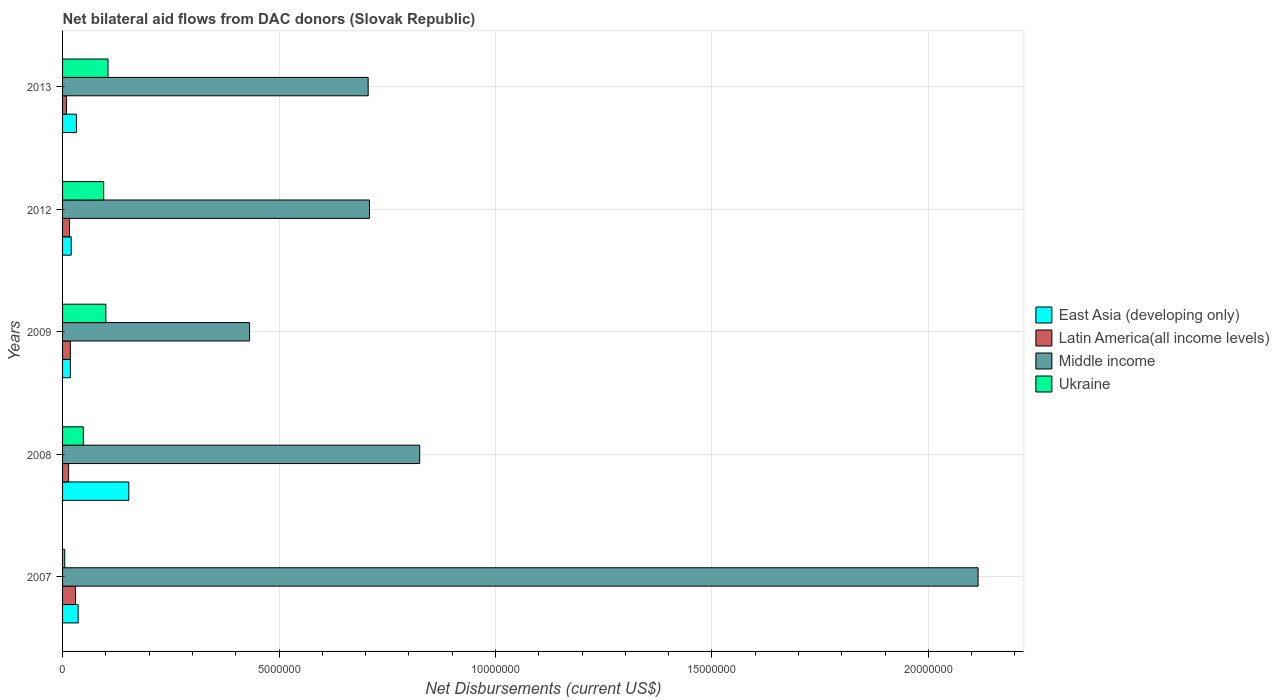How many groups of bars are there?
Your response must be concise. 5. Are the number of bars per tick equal to the number of legend labels?
Your response must be concise. Yes. Are the number of bars on each tick of the Y-axis equal?
Offer a terse response. Yes. How many bars are there on the 1st tick from the top?
Offer a very short reply. 4. What is the label of the 1st group of bars from the top?
Provide a succinct answer. 2013. What is the net bilateral aid flows in Middle income in 2012?
Provide a succinct answer. 7.09e+06. Across all years, what is the maximum net bilateral aid flows in Latin America(all income levels)?
Provide a short and direct response. 3.00e+05. What is the total net bilateral aid flows in Latin America(all income levels) in the graph?
Your response must be concise. 8.70e+05. What is the difference between the net bilateral aid flows in Middle income in 2008 and that in 2012?
Offer a very short reply. 1.16e+06. What is the difference between the net bilateral aid flows in Ukraine in 2009 and the net bilateral aid flows in Middle income in 2008?
Ensure brevity in your answer.  -7.25e+06. What is the average net bilateral aid flows in East Asia (developing only) per year?
Provide a short and direct response. 5.18e+05. In the year 2009, what is the difference between the net bilateral aid flows in East Asia (developing only) and net bilateral aid flows in Latin America(all income levels)?
Ensure brevity in your answer.  0. In how many years, is the net bilateral aid flows in Middle income greater than 2000000 US$?
Keep it short and to the point. 5. What is the ratio of the net bilateral aid flows in Middle income in 2008 to that in 2012?
Your answer should be compact. 1.16. Is the net bilateral aid flows in East Asia (developing only) in 2009 less than that in 2013?
Provide a short and direct response. Yes. Is the difference between the net bilateral aid flows in East Asia (developing only) in 2012 and 2013 greater than the difference between the net bilateral aid flows in Latin America(all income levels) in 2012 and 2013?
Your answer should be compact. No. What is the difference between the highest and the lowest net bilateral aid flows in Middle income?
Ensure brevity in your answer.  1.68e+07. In how many years, is the net bilateral aid flows in Ukraine greater than the average net bilateral aid flows in Ukraine taken over all years?
Offer a terse response. 3. Is the sum of the net bilateral aid flows in Middle income in 2007 and 2012 greater than the maximum net bilateral aid flows in Latin America(all income levels) across all years?
Provide a succinct answer. Yes. Is it the case that in every year, the sum of the net bilateral aid flows in Latin America(all income levels) and net bilateral aid flows in East Asia (developing only) is greater than the sum of net bilateral aid flows in Middle income and net bilateral aid flows in Ukraine?
Offer a terse response. Yes. What does the 1st bar from the top in 2007 represents?
Offer a terse response. Ukraine. What does the 1st bar from the bottom in 2008 represents?
Your response must be concise. East Asia (developing only). Is it the case that in every year, the sum of the net bilateral aid flows in Latin America(all income levels) and net bilateral aid flows in Ukraine is greater than the net bilateral aid flows in East Asia (developing only)?
Make the answer very short. No. Are all the bars in the graph horizontal?
Offer a terse response. Yes. How many years are there in the graph?
Offer a terse response. 5. What is the difference between two consecutive major ticks on the X-axis?
Your answer should be very brief. 5.00e+06. Are the values on the major ticks of X-axis written in scientific E-notation?
Offer a terse response. No. Does the graph contain grids?
Your answer should be compact. Yes. What is the title of the graph?
Your answer should be compact. Net bilateral aid flows from DAC donors (Slovak Republic). Does "Qatar" appear as one of the legend labels in the graph?
Give a very brief answer. No. What is the label or title of the X-axis?
Keep it short and to the point. Net Disbursements (current US$). What is the label or title of the Y-axis?
Give a very brief answer. Years. What is the Net Disbursements (current US$) in East Asia (developing only) in 2007?
Keep it short and to the point. 3.60e+05. What is the Net Disbursements (current US$) of Latin America(all income levels) in 2007?
Make the answer very short. 3.00e+05. What is the Net Disbursements (current US$) of Middle income in 2007?
Make the answer very short. 2.12e+07. What is the Net Disbursements (current US$) in Ukraine in 2007?
Your response must be concise. 5.00e+04. What is the Net Disbursements (current US$) of East Asia (developing only) in 2008?
Offer a very short reply. 1.53e+06. What is the Net Disbursements (current US$) in Middle income in 2008?
Your answer should be compact. 8.25e+06. What is the Net Disbursements (current US$) of Ukraine in 2008?
Provide a short and direct response. 4.80e+05. What is the Net Disbursements (current US$) of Middle income in 2009?
Provide a succinct answer. 4.32e+06. What is the Net Disbursements (current US$) of Latin America(all income levels) in 2012?
Offer a very short reply. 1.60e+05. What is the Net Disbursements (current US$) in Middle income in 2012?
Ensure brevity in your answer.  7.09e+06. What is the Net Disbursements (current US$) in Ukraine in 2012?
Provide a succinct answer. 9.50e+05. What is the Net Disbursements (current US$) of Latin America(all income levels) in 2013?
Ensure brevity in your answer.  9.00e+04. What is the Net Disbursements (current US$) in Middle income in 2013?
Your answer should be very brief. 7.06e+06. What is the Net Disbursements (current US$) in Ukraine in 2013?
Make the answer very short. 1.05e+06. Across all years, what is the maximum Net Disbursements (current US$) of East Asia (developing only)?
Your answer should be compact. 1.53e+06. Across all years, what is the maximum Net Disbursements (current US$) of Middle income?
Keep it short and to the point. 2.12e+07. Across all years, what is the maximum Net Disbursements (current US$) of Ukraine?
Your answer should be compact. 1.05e+06. Across all years, what is the minimum Net Disbursements (current US$) of East Asia (developing only)?
Provide a short and direct response. 1.80e+05. Across all years, what is the minimum Net Disbursements (current US$) of Middle income?
Make the answer very short. 4.32e+06. What is the total Net Disbursements (current US$) of East Asia (developing only) in the graph?
Keep it short and to the point. 2.59e+06. What is the total Net Disbursements (current US$) in Latin America(all income levels) in the graph?
Your answer should be compact. 8.70e+05. What is the total Net Disbursements (current US$) in Middle income in the graph?
Offer a terse response. 4.79e+07. What is the total Net Disbursements (current US$) in Ukraine in the graph?
Offer a terse response. 3.53e+06. What is the difference between the Net Disbursements (current US$) of East Asia (developing only) in 2007 and that in 2008?
Give a very brief answer. -1.17e+06. What is the difference between the Net Disbursements (current US$) of Latin America(all income levels) in 2007 and that in 2008?
Make the answer very short. 1.60e+05. What is the difference between the Net Disbursements (current US$) in Middle income in 2007 and that in 2008?
Your response must be concise. 1.29e+07. What is the difference between the Net Disbursements (current US$) in Ukraine in 2007 and that in 2008?
Provide a short and direct response. -4.30e+05. What is the difference between the Net Disbursements (current US$) of East Asia (developing only) in 2007 and that in 2009?
Your response must be concise. 1.80e+05. What is the difference between the Net Disbursements (current US$) of Middle income in 2007 and that in 2009?
Offer a very short reply. 1.68e+07. What is the difference between the Net Disbursements (current US$) of Ukraine in 2007 and that in 2009?
Offer a terse response. -9.50e+05. What is the difference between the Net Disbursements (current US$) of Middle income in 2007 and that in 2012?
Provide a succinct answer. 1.41e+07. What is the difference between the Net Disbursements (current US$) in Ukraine in 2007 and that in 2012?
Offer a very short reply. -9.00e+05. What is the difference between the Net Disbursements (current US$) of Middle income in 2007 and that in 2013?
Give a very brief answer. 1.41e+07. What is the difference between the Net Disbursements (current US$) in East Asia (developing only) in 2008 and that in 2009?
Provide a succinct answer. 1.35e+06. What is the difference between the Net Disbursements (current US$) of Latin America(all income levels) in 2008 and that in 2009?
Make the answer very short. -4.00e+04. What is the difference between the Net Disbursements (current US$) in Middle income in 2008 and that in 2009?
Provide a succinct answer. 3.93e+06. What is the difference between the Net Disbursements (current US$) in Ukraine in 2008 and that in 2009?
Offer a terse response. -5.20e+05. What is the difference between the Net Disbursements (current US$) in East Asia (developing only) in 2008 and that in 2012?
Ensure brevity in your answer.  1.33e+06. What is the difference between the Net Disbursements (current US$) in Latin America(all income levels) in 2008 and that in 2012?
Give a very brief answer. -2.00e+04. What is the difference between the Net Disbursements (current US$) in Middle income in 2008 and that in 2012?
Provide a succinct answer. 1.16e+06. What is the difference between the Net Disbursements (current US$) of Ukraine in 2008 and that in 2012?
Your response must be concise. -4.70e+05. What is the difference between the Net Disbursements (current US$) of East Asia (developing only) in 2008 and that in 2013?
Make the answer very short. 1.21e+06. What is the difference between the Net Disbursements (current US$) of Middle income in 2008 and that in 2013?
Make the answer very short. 1.19e+06. What is the difference between the Net Disbursements (current US$) of Ukraine in 2008 and that in 2013?
Give a very brief answer. -5.70e+05. What is the difference between the Net Disbursements (current US$) of East Asia (developing only) in 2009 and that in 2012?
Offer a very short reply. -2.00e+04. What is the difference between the Net Disbursements (current US$) of Latin America(all income levels) in 2009 and that in 2012?
Keep it short and to the point. 2.00e+04. What is the difference between the Net Disbursements (current US$) of Middle income in 2009 and that in 2012?
Keep it short and to the point. -2.77e+06. What is the difference between the Net Disbursements (current US$) of Ukraine in 2009 and that in 2012?
Your answer should be very brief. 5.00e+04. What is the difference between the Net Disbursements (current US$) of East Asia (developing only) in 2009 and that in 2013?
Provide a succinct answer. -1.40e+05. What is the difference between the Net Disbursements (current US$) of Latin America(all income levels) in 2009 and that in 2013?
Offer a very short reply. 9.00e+04. What is the difference between the Net Disbursements (current US$) in Middle income in 2009 and that in 2013?
Your response must be concise. -2.74e+06. What is the difference between the Net Disbursements (current US$) in East Asia (developing only) in 2012 and that in 2013?
Your response must be concise. -1.20e+05. What is the difference between the Net Disbursements (current US$) in Middle income in 2012 and that in 2013?
Provide a short and direct response. 3.00e+04. What is the difference between the Net Disbursements (current US$) in East Asia (developing only) in 2007 and the Net Disbursements (current US$) in Latin America(all income levels) in 2008?
Your answer should be compact. 2.20e+05. What is the difference between the Net Disbursements (current US$) in East Asia (developing only) in 2007 and the Net Disbursements (current US$) in Middle income in 2008?
Give a very brief answer. -7.89e+06. What is the difference between the Net Disbursements (current US$) of East Asia (developing only) in 2007 and the Net Disbursements (current US$) of Ukraine in 2008?
Keep it short and to the point. -1.20e+05. What is the difference between the Net Disbursements (current US$) of Latin America(all income levels) in 2007 and the Net Disbursements (current US$) of Middle income in 2008?
Your response must be concise. -7.95e+06. What is the difference between the Net Disbursements (current US$) of Middle income in 2007 and the Net Disbursements (current US$) of Ukraine in 2008?
Offer a terse response. 2.07e+07. What is the difference between the Net Disbursements (current US$) in East Asia (developing only) in 2007 and the Net Disbursements (current US$) in Middle income in 2009?
Offer a very short reply. -3.96e+06. What is the difference between the Net Disbursements (current US$) of East Asia (developing only) in 2007 and the Net Disbursements (current US$) of Ukraine in 2009?
Give a very brief answer. -6.40e+05. What is the difference between the Net Disbursements (current US$) of Latin America(all income levels) in 2007 and the Net Disbursements (current US$) of Middle income in 2009?
Keep it short and to the point. -4.02e+06. What is the difference between the Net Disbursements (current US$) in Latin America(all income levels) in 2007 and the Net Disbursements (current US$) in Ukraine in 2009?
Provide a succinct answer. -7.00e+05. What is the difference between the Net Disbursements (current US$) in Middle income in 2007 and the Net Disbursements (current US$) in Ukraine in 2009?
Your response must be concise. 2.02e+07. What is the difference between the Net Disbursements (current US$) in East Asia (developing only) in 2007 and the Net Disbursements (current US$) in Middle income in 2012?
Ensure brevity in your answer.  -6.73e+06. What is the difference between the Net Disbursements (current US$) in East Asia (developing only) in 2007 and the Net Disbursements (current US$) in Ukraine in 2012?
Your response must be concise. -5.90e+05. What is the difference between the Net Disbursements (current US$) of Latin America(all income levels) in 2007 and the Net Disbursements (current US$) of Middle income in 2012?
Keep it short and to the point. -6.79e+06. What is the difference between the Net Disbursements (current US$) in Latin America(all income levels) in 2007 and the Net Disbursements (current US$) in Ukraine in 2012?
Provide a succinct answer. -6.50e+05. What is the difference between the Net Disbursements (current US$) in Middle income in 2007 and the Net Disbursements (current US$) in Ukraine in 2012?
Make the answer very short. 2.02e+07. What is the difference between the Net Disbursements (current US$) in East Asia (developing only) in 2007 and the Net Disbursements (current US$) in Middle income in 2013?
Your response must be concise. -6.70e+06. What is the difference between the Net Disbursements (current US$) of East Asia (developing only) in 2007 and the Net Disbursements (current US$) of Ukraine in 2013?
Provide a short and direct response. -6.90e+05. What is the difference between the Net Disbursements (current US$) of Latin America(all income levels) in 2007 and the Net Disbursements (current US$) of Middle income in 2013?
Ensure brevity in your answer.  -6.76e+06. What is the difference between the Net Disbursements (current US$) in Latin America(all income levels) in 2007 and the Net Disbursements (current US$) in Ukraine in 2013?
Make the answer very short. -7.50e+05. What is the difference between the Net Disbursements (current US$) of Middle income in 2007 and the Net Disbursements (current US$) of Ukraine in 2013?
Your answer should be compact. 2.01e+07. What is the difference between the Net Disbursements (current US$) in East Asia (developing only) in 2008 and the Net Disbursements (current US$) in Latin America(all income levels) in 2009?
Your answer should be compact. 1.35e+06. What is the difference between the Net Disbursements (current US$) of East Asia (developing only) in 2008 and the Net Disbursements (current US$) of Middle income in 2009?
Your response must be concise. -2.79e+06. What is the difference between the Net Disbursements (current US$) in East Asia (developing only) in 2008 and the Net Disbursements (current US$) in Ukraine in 2009?
Offer a terse response. 5.30e+05. What is the difference between the Net Disbursements (current US$) in Latin America(all income levels) in 2008 and the Net Disbursements (current US$) in Middle income in 2009?
Your response must be concise. -4.18e+06. What is the difference between the Net Disbursements (current US$) of Latin America(all income levels) in 2008 and the Net Disbursements (current US$) of Ukraine in 2009?
Your answer should be compact. -8.60e+05. What is the difference between the Net Disbursements (current US$) in Middle income in 2008 and the Net Disbursements (current US$) in Ukraine in 2009?
Ensure brevity in your answer.  7.25e+06. What is the difference between the Net Disbursements (current US$) of East Asia (developing only) in 2008 and the Net Disbursements (current US$) of Latin America(all income levels) in 2012?
Your response must be concise. 1.37e+06. What is the difference between the Net Disbursements (current US$) in East Asia (developing only) in 2008 and the Net Disbursements (current US$) in Middle income in 2012?
Your response must be concise. -5.56e+06. What is the difference between the Net Disbursements (current US$) of East Asia (developing only) in 2008 and the Net Disbursements (current US$) of Ukraine in 2012?
Keep it short and to the point. 5.80e+05. What is the difference between the Net Disbursements (current US$) of Latin America(all income levels) in 2008 and the Net Disbursements (current US$) of Middle income in 2012?
Ensure brevity in your answer.  -6.95e+06. What is the difference between the Net Disbursements (current US$) in Latin America(all income levels) in 2008 and the Net Disbursements (current US$) in Ukraine in 2012?
Your answer should be very brief. -8.10e+05. What is the difference between the Net Disbursements (current US$) in Middle income in 2008 and the Net Disbursements (current US$) in Ukraine in 2012?
Offer a terse response. 7.30e+06. What is the difference between the Net Disbursements (current US$) in East Asia (developing only) in 2008 and the Net Disbursements (current US$) in Latin America(all income levels) in 2013?
Keep it short and to the point. 1.44e+06. What is the difference between the Net Disbursements (current US$) of East Asia (developing only) in 2008 and the Net Disbursements (current US$) of Middle income in 2013?
Offer a terse response. -5.53e+06. What is the difference between the Net Disbursements (current US$) of East Asia (developing only) in 2008 and the Net Disbursements (current US$) of Ukraine in 2013?
Give a very brief answer. 4.80e+05. What is the difference between the Net Disbursements (current US$) in Latin America(all income levels) in 2008 and the Net Disbursements (current US$) in Middle income in 2013?
Offer a terse response. -6.92e+06. What is the difference between the Net Disbursements (current US$) in Latin America(all income levels) in 2008 and the Net Disbursements (current US$) in Ukraine in 2013?
Your response must be concise. -9.10e+05. What is the difference between the Net Disbursements (current US$) of Middle income in 2008 and the Net Disbursements (current US$) of Ukraine in 2013?
Ensure brevity in your answer.  7.20e+06. What is the difference between the Net Disbursements (current US$) of East Asia (developing only) in 2009 and the Net Disbursements (current US$) of Middle income in 2012?
Offer a terse response. -6.91e+06. What is the difference between the Net Disbursements (current US$) of East Asia (developing only) in 2009 and the Net Disbursements (current US$) of Ukraine in 2012?
Keep it short and to the point. -7.70e+05. What is the difference between the Net Disbursements (current US$) of Latin America(all income levels) in 2009 and the Net Disbursements (current US$) of Middle income in 2012?
Provide a short and direct response. -6.91e+06. What is the difference between the Net Disbursements (current US$) of Latin America(all income levels) in 2009 and the Net Disbursements (current US$) of Ukraine in 2012?
Give a very brief answer. -7.70e+05. What is the difference between the Net Disbursements (current US$) of Middle income in 2009 and the Net Disbursements (current US$) of Ukraine in 2012?
Keep it short and to the point. 3.37e+06. What is the difference between the Net Disbursements (current US$) in East Asia (developing only) in 2009 and the Net Disbursements (current US$) in Middle income in 2013?
Keep it short and to the point. -6.88e+06. What is the difference between the Net Disbursements (current US$) in East Asia (developing only) in 2009 and the Net Disbursements (current US$) in Ukraine in 2013?
Keep it short and to the point. -8.70e+05. What is the difference between the Net Disbursements (current US$) in Latin America(all income levels) in 2009 and the Net Disbursements (current US$) in Middle income in 2013?
Provide a short and direct response. -6.88e+06. What is the difference between the Net Disbursements (current US$) in Latin America(all income levels) in 2009 and the Net Disbursements (current US$) in Ukraine in 2013?
Provide a short and direct response. -8.70e+05. What is the difference between the Net Disbursements (current US$) of Middle income in 2009 and the Net Disbursements (current US$) of Ukraine in 2013?
Provide a succinct answer. 3.27e+06. What is the difference between the Net Disbursements (current US$) in East Asia (developing only) in 2012 and the Net Disbursements (current US$) in Middle income in 2013?
Provide a short and direct response. -6.86e+06. What is the difference between the Net Disbursements (current US$) in East Asia (developing only) in 2012 and the Net Disbursements (current US$) in Ukraine in 2013?
Your answer should be very brief. -8.50e+05. What is the difference between the Net Disbursements (current US$) of Latin America(all income levels) in 2012 and the Net Disbursements (current US$) of Middle income in 2013?
Your response must be concise. -6.90e+06. What is the difference between the Net Disbursements (current US$) in Latin America(all income levels) in 2012 and the Net Disbursements (current US$) in Ukraine in 2013?
Give a very brief answer. -8.90e+05. What is the difference between the Net Disbursements (current US$) in Middle income in 2012 and the Net Disbursements (current US$) in Ukraine in 2013?
Make the answer very short. 6.04e+06. What is the average Net Disbursements (current US$) in East Asia (developing only) per year?
Provide a succinct answer. 5.18e+05. What is the average Net Disbursements (current US$) of Latin America(all income levels) per year?
Make the answer very short. 1.74e+05. What is the average Net Disbursements (current US$) in Middle income per year?
Your answer should be very brief. 9.57e+06. What is the average Net Disbursements (current US$) in Ukraine per year?
Your answer should be compact. 7.06e+05. In the year 2007, what is the difference between the Net Disbursements (current US$) in East Asia (developing only) and Net Disbursements (current US$) in Latin America(all income levels)?
Your answer should be very brief. 6.00e+04. In the year 2007, what is the difference between the Net Disbursements (current US$) in East Asia (developing only) and Net Disbursements (current US$) in Middle income?
Your answer should be compact. -2.08e+07. In the year 2007, what is the difference between the Net Disbursements (current US$) of Latin America(all income levels) and Net Disbursements (current US$) of Middle income?
Your answer should be very brief. -2.08e+07. In the year 2007, what is the difference between the Net Disbursements (current US$) in Middle income and Net Disbursements (current US$) in Ukraine?
Offer a terse response. 2.11e+07. In the year 2008, what is the difference between the Net Disbursements (current US$) in East Asia (developing only) and Net Disbursements (current US$) in Latin America(all income levels)?
Your answer should be very brief. 1.39e+06. In the year 2008, what is the difference between the Net Disbursements (current US$) of East Asia (developing only) and Net Disbursements (current US$) of Middle income?
Your answer should be compact. -6.72e+06. In the year 2008, what is the difference between the Net Disbursements (current US$) of East Asia (developing only) and Net Disbursements (current US$) of Ukraine?
Your answer should be very brief. 1.05e+06. In the year 2008, what is the difference between the Net Disbursements (current US$) in Latin America(all income levels) and Net Disbursements (current US$) in Middle income?
Provide a succinct answer. -8.11e+06. In the year 2008, what is the difference between the Net Disbursements (current US$) of Middle income and Net Disbursements (current US$) of Ukraine?
Give a very brief answer. 7.77e+06. In the year 2009, what is the difference between the Net Disbursements (current US$) of East Asia (developing only) and Net Disbursements (current US$) of Latin America(all income levels)?
Offer a terse response. 0. In the year 2009, what is the difference between the Net Disbursements (current US$) in East Asia (developing only) and Net Disbursements (current US$) in Middle income?
Make the answer very short. -4.14e+06. In the year 2009, what is the difference between the Net Disbursements (current US$) in East Asia (developing only) and Net Disbursements (current US$) in Ukraine?
Make the answer very short. -8.20e+05. In the year 2009, what is the difference between the Net Disbursements (current US$) of Latin America(all income levels) and Net Disbursements (current US$) of Middle income?
Ensure brevity in your answer.  -4.14e+06. In the year 2009, what is the difference between the Net Disbursements (current US$) in Latin America(all income levels) and Net Disbursements (current US$) in Ukraine?
Ensure brevity in your answer.  -8.20e+05. In the year 2009, what is the difference between the Net Disbursements (current US$) of Middle income and Net Disbursements (current US$) of Ukraine?
Provide a short and direct response. 3.32e+06. In the year 2012, what is the difference between the Net Disbursements (current US$) of East Asia (developing only) and Net Disbursements (current US$) of Middle income?
Provide a succinct answer. -6.89e+06. In the year 2012, what is the difference between the Net Disbursements (current US$) of East Asia (developing only) and Net Disbursements (current US$) of Ukraine?
Provide a short and direct response. -7.50e+05. In the year 2012, what is the difference between the Net Disbursements (current US$) in Latin America(all income levels) and Net Disbursements (current US$) in Middle income?
Provide a short and direct response. -6.93e+06. In the year 2012, what is the difference between the Net Disbursements (current US$) in Latin America(all income levels) and Net Disbursements (current US$) in Ukraine?
Make the answer very short. -7.90e+05. In the year 2012, what is the difference between the Net Disbursements (current US$) of Middle income and Net Disbursements (current US$) of Ukraine?
Your response must be concise. 6.14e+06. In the year 2013, what is the difference between the Net Disbursements (current US$) in East Asia (developing only) and Net Disbursements (current US$) in Middle income?
Ensure brevity in your answer.  -6.74e+06. In the year 2013, what is the difference between the Net Disbursements (current US$) in East Asia (developing only) and Net Disbursements (current US$) in Ukraine?
Provide a succinct answer. -7.30e+05. In the year 2013, what is the difference between the Net Disbursements (current US$) of Latin America(all income levels) and Net Disbursements (current US$) of Middle income?
Offer a terse response. -6.97e+06. In the year 2013, what is the difference between the Net Disbursements (current US$) in Latin America(all income levels) and Net Disbursements (current US$) in Ukraine?
Provide a short and direct response. -9.60e+05. In the year 2013, what is the difference between the Net Disbursements (current US$) of Middle income and Net Disbursements (current US$) of Ukraine?
Ensure brevity in your answer.  6.01e+06. What is the ratio of the Net Disbursements (current US$) in East Asia (developing only) in 2007 to that in 2008?
Your answer should be compact. 0.24. What is the ratio of the Net Disbursements (current US$) in Latin America(all income levels) in 2007 to that in 2008?
Make the answer very short. 2.14. What is the ratio of the Net Disbursements (current US$) in Middle income in 2007 to that in 2008?
Give a very brief answer. 2.56. What is the ratio of the Net Disbursements (current US$) of Ukraine in 2007 to that in 2008?
Your answer should be compact. 0.1. What is the ratio of the Net Disbursements (current US$) in East Asia (developing only) in 2007 to that in 2009?
Your answer should be compact. 2. What is the ratio of the Net Disbursements (current US$) of Middle income in 2007 to that in 2009?
Keep it short and to the point. 4.9. What is the ratio of the Net Disbursements (current US$) of Ukraine in 2007 to that in 2009?
Offer a very short reply. 0.05. What is the ratio of the Net Disbursements (current US$) of Latin America(all income levels) in 2007 to that in 2012?
Give a very brief answer. 1.88. What is the ratio of the Net Disbursements (current US$) of Middle income in 2007 to that in 2012?
Offer a terse response. 2.98. What is the ratio of the Net Disbursements (current US$) in Ukraine in 2007 to that in 2012?
Give a very brief answer. 0.05. What is the ratio of the Net Disbursements (current US$) of Middle income in 2007 to that in 2013?
Provide a succinct answer. 3. What is the ratio of the Net Disbursements (current US$) in Ukraine in 2007 to that in 2013?
Offer a terse response. 0.05. What is the ratio of the Net Disbursements (current US$) in East Asia (developing only) in 2008 to that in 2009?
Make the answer very short. 8.5. What is the ratio of the Net Disbursements (current US$) in Middle income in 2008 to that in 2009?
Your answer should be compact. 1.91. What is the ratio of the Net Disbursements (current US$) of Ukraine in 2008 to that in 2009?
Ensure brevity in your answer.  0.48. What is the ratio of the Net Disbursements (current US$) in East Asia (developing only) in 2008 to that in 2012?
Provide a succinct answer. 7.65. What is the ratio of the Net Disbursements (current US$) in Middle income in 2008 to that in 2012?
Your answer should be very brief. 1.16. What is the ratio of the Net Disbursements (current US$) of Ukraine in 2008 to that in 2012?
Give a very brief answer. 0.51. What is the ratio of the Net Disbursements (current US$) in East Asia (developing only) in 2008 to that in 2013?
Your answer should be compact. 4.78. What is the ratio of the Net Disbursements (current US$) of Latin America(all income levels) in 2008 to that in 2013?
Keep it short and to the point. 1.56. What is the ratio of the Net Disbursements (current US$) of Middle income in 2008 to that in 2013?
Provide a succinct answer. 1.17. What is the ratio of the Net Disbursements (current US$) in Ukraine in 2008 to that in 2013?
Your answer should be very brief. 0.46. What is the ratio of the Net Disbursements (current US$) of Latin America(all income levels) in 2009 to that in 2012?
Make the answer very short. 1.12. What is the ratio of the Net Disbursements (current US$) in Middle income in 2009 to that in 2012?
Make the answer very short. 0.61. What is the ratio of the Net Disbursements (current US$) in Ukraine in 2009 to that in 2012?
Offer a very short reply. 1.05. What is the ratio of the Net Disbursements (current US$) of East Asia (developing only) in 2009 to that in 2013?
Make the answer very short. 0.56. What is the ratio of the Net Disbursements (current US$) of Middle income in 2009 to that in 2013?
Ensure brevity in your answer.  0.61. What is the ratio of the Net Disbursements (current US$) in Ukraine in 2009 to that in 2013?
Offer a very short reply. 0.95. What is the ratio of the Net Disbursements (current US$) in Latin America(all income levels) in 2012 to that in 2013?
Offer a terse response. 1.78. What is the ratio of the Net Disbursements (current US$) of Middle income in 2012 to that in 2013?
Provide a succinct answer. 1. What is the ratio of the Net Disbursements (current US$) of Ukraine in 2012 to that in 2013?
Offer a terse response. 0.9. What is the difference between the highest and the second highest Net Disbursements (current US$) in East Asia (developing only)?
Make the answer very short. 1.17e+06. What is the difference between the highest and the second highest Net Disbursements (current US$) of Latin America(all income levels)?
Offer a very short reply. 1.20e+05. What is the difference between the highest and the second highest Net Disbursements (current US$) of Middle income?
Ensure brevity in your answer.  1.29e+07. What is the difference between the highest and the second highest Net Disbursements (current US$) of Ukraine?
Give a very brief answer. 5.00e+04. What is the difference between the highest and the lowest Net Disbursements (current US$) in East Asia (developing only)?
Keep it short and to the point. 1.35e+06. What is the difference between the highest and the lowest Net Disbursements (current US$) in Middle income?
Make the answer very short. 1.68e+07. What is the difference between the highest and the lowest Net Disbursements (current US$) in Ukraine?
Keep it short and to the point. 1.00e+06. 